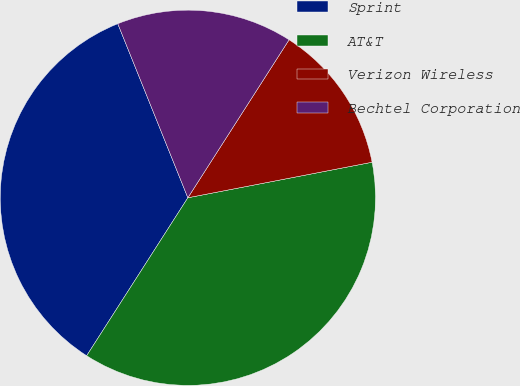Convert chart. <chart><loc_0><loc_0><loc_500><loc_500><pie_chart><fcel>Sprint<fcel>AT&T<fcel>Verizon Wireless<fcel>Bechtel Corporation<nl><fcel>34.84%<fcel>37.1%<fcel>12.9%<fcel>15.16%<nl></chart> 